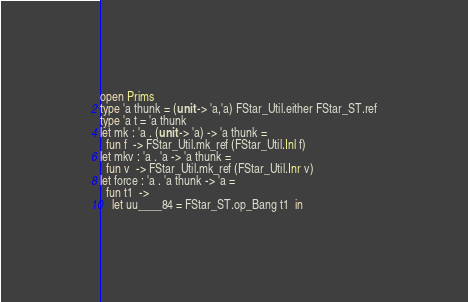<code> <loc_0><loc_0><loc_500><loc_500><_OCaml_>open Prims
type 'a thunk = (unit -> 'a,'a) FStar_Util.either FStar_ST.ref
type 'a t = 'a thunk
let mk : 'a . (unit -> 'a) -> 'a thunk =
  fun f  -> FStar_Util.mk_ref (FStar_Util.Inl f) 
let mkv : 'a . 'a -> 'a thunk =
  fun v  -> FStar_Util.mk_ref (FStar_Util.Inr v) 
let force : 'a . 'a thunk -> 'a =
  fun t1  ->
    let uu____84 = FStar_ST.op_Bang t1  in</code> 